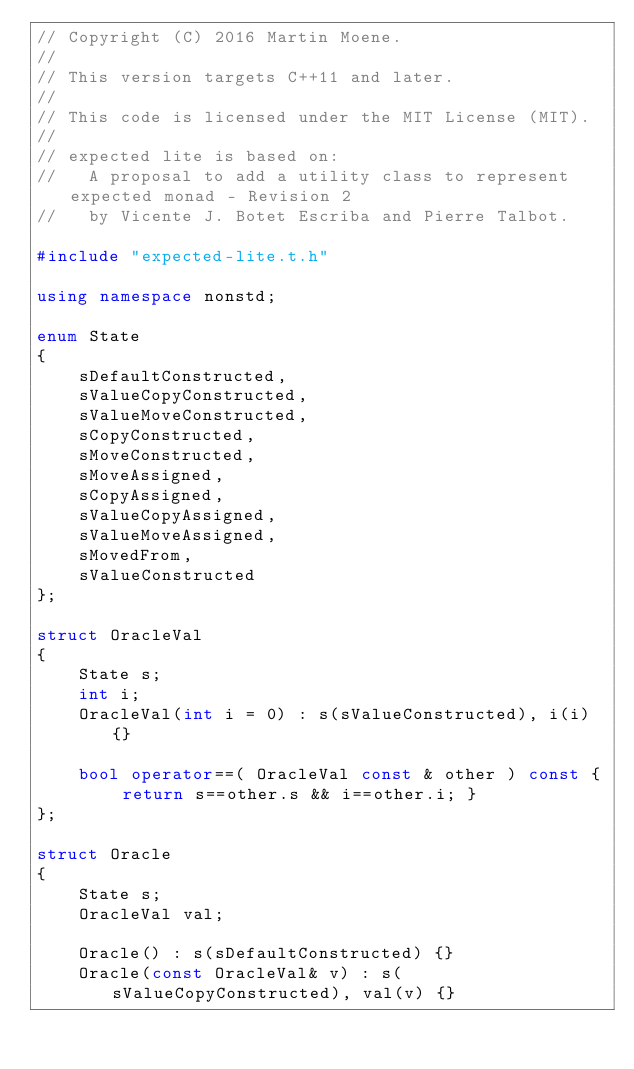Convert code to text. <code><loc_0><loc_0><loc_500><loc_500><_C++_>// Copyright (C) 2016 Martin Moene.
//
// This version targets C++11 and later.
//
// This code is licensed under the MIT License (MIT).
//
// expected lite is based on:
//   A proposal to add a utility class to represent expected monad - Revision 2
//   by Vicente J. Botet Escriba and Pierre Talbot.

#include "expected-lite.t.h"

using namespace nonstd;

enum State
{
    sDefaultConstructed,
    sValueCopyConstructed,
    sValueMoveConstructed,
    sCopyConstructed,
    sMoveConstructed,
    sMoveAssigned,
    sCopyAssigned,
    sValueCopyAssigned,
    sValueMoveAssigned,
    sMovedFrom,
    sValueConstructed
};

struct OracleVal
{
    State s;
    int i;
    OracleVal(int i = 0) : s(sValueConstructed), i(i) {}

    bool operator==( OracleVal const & other ) const { return s==other.s && i==other.i; }
};

struct Oracle
{
    State s;
    OracleVal val;

    Oracle() : s(sDefaultConstructed) {}
    Oracle(const OracleVal& v) : s(sValueCopyConstructed), val(v) {}</code> 